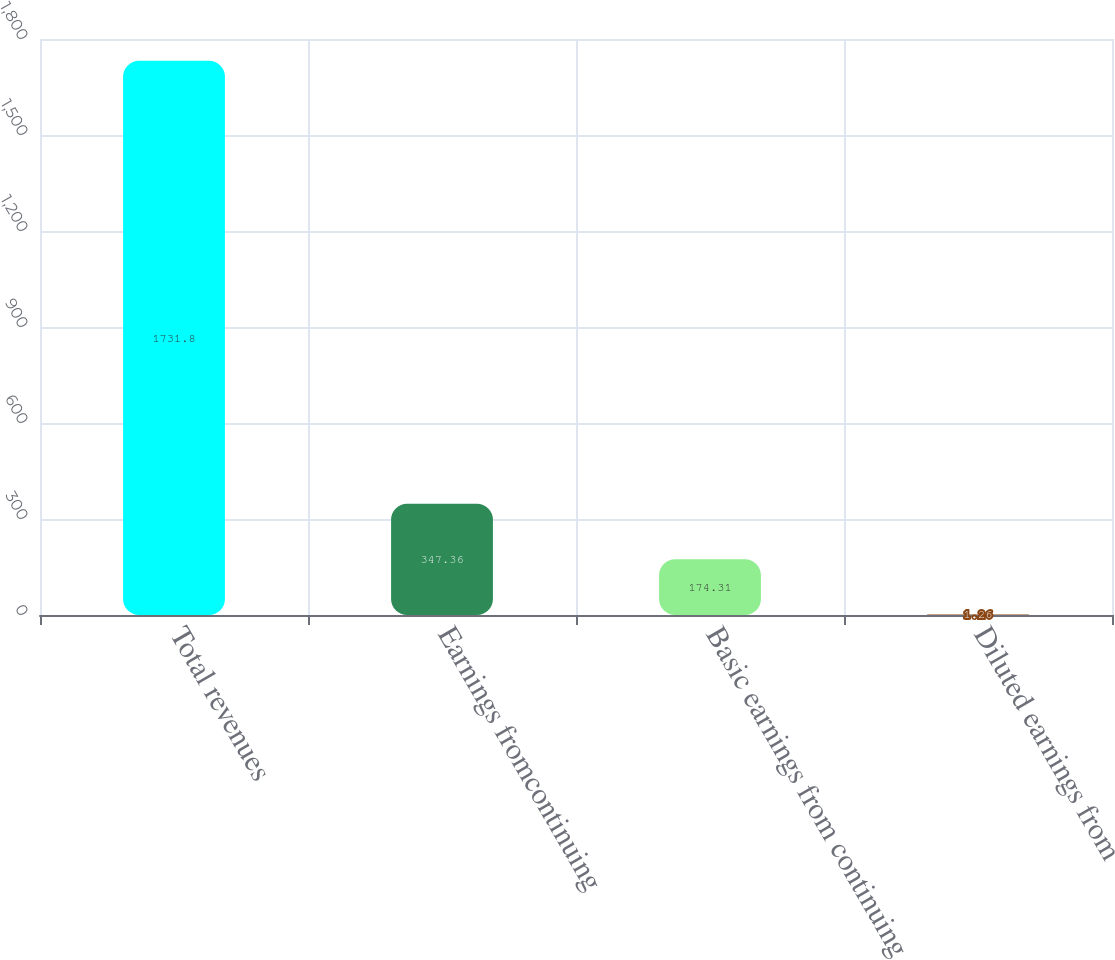<chart> <loc_0><loc_0><loc_500><loc_500><bar_chart><fcel>Total revenues<fcel>Earnings fromcontinuing<fcel>Basic earnings from continuing<fcel>Diluted earnings from<nl><fcel>1731.8<fcel>347.36<fcel>174.31<fcel>1.26<nl></chart> 